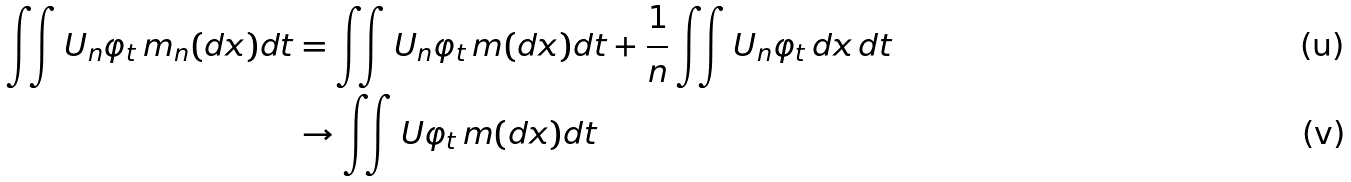<formula> <loc_0><loc_0><loc_500><loc_500>\iint U _ { n } \varphi _ { t } \, m _ { n } ( d x ) d t & = \iint U _ { n } \varphi _ { t } \, m ( d x ) d t + \frac { 1 } { n } \iint U _ { n } \varphi _ { t } \, d x \, d t \\ & \to \iint U \varphi _ { t } \, m ( d x ) d t</formula> 